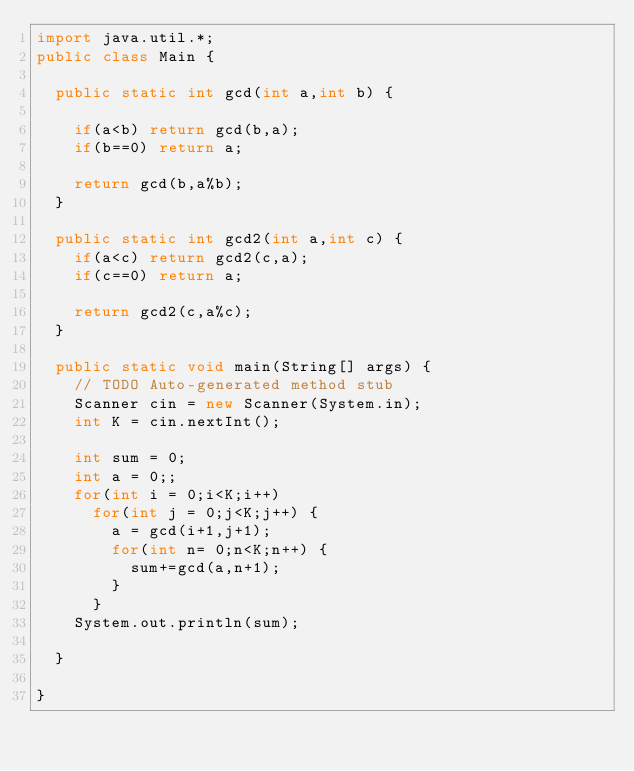<code> <loc_0><loc_0><loc_500><loc_500><_Java_>import java.util.*;
public class Main {

	public static int gcd(int a,int b) {
		
		if(a<b) return gcd(b,a);
		if(b==0) return a;
		
		return gcd(b,a%b);
	}
	
	public static int gcd2(int a,int c) {
		if(a<c) return gcd2(c,a);
		if(c==0) return a;
		
		return gcd2(c,a%c);
	}
	
	public static void main(String[] args) {
		// TODO Auto-generated method stub
		Scanner cin = new Scanner(System.in);
		int K = cin.nextInt();
		
		int sum = 0;
		int a = 0;;
		for(int i = 0;i<K;i++)
			for(int j = 0;j<K;j++) {
				a = gcd(i+1,j+1);
				for(int n= 0;n<K;n++) {
					sum+=gcd(a,n+1);
				}
			}
		System.out.println(sum);

	}

}</code> 